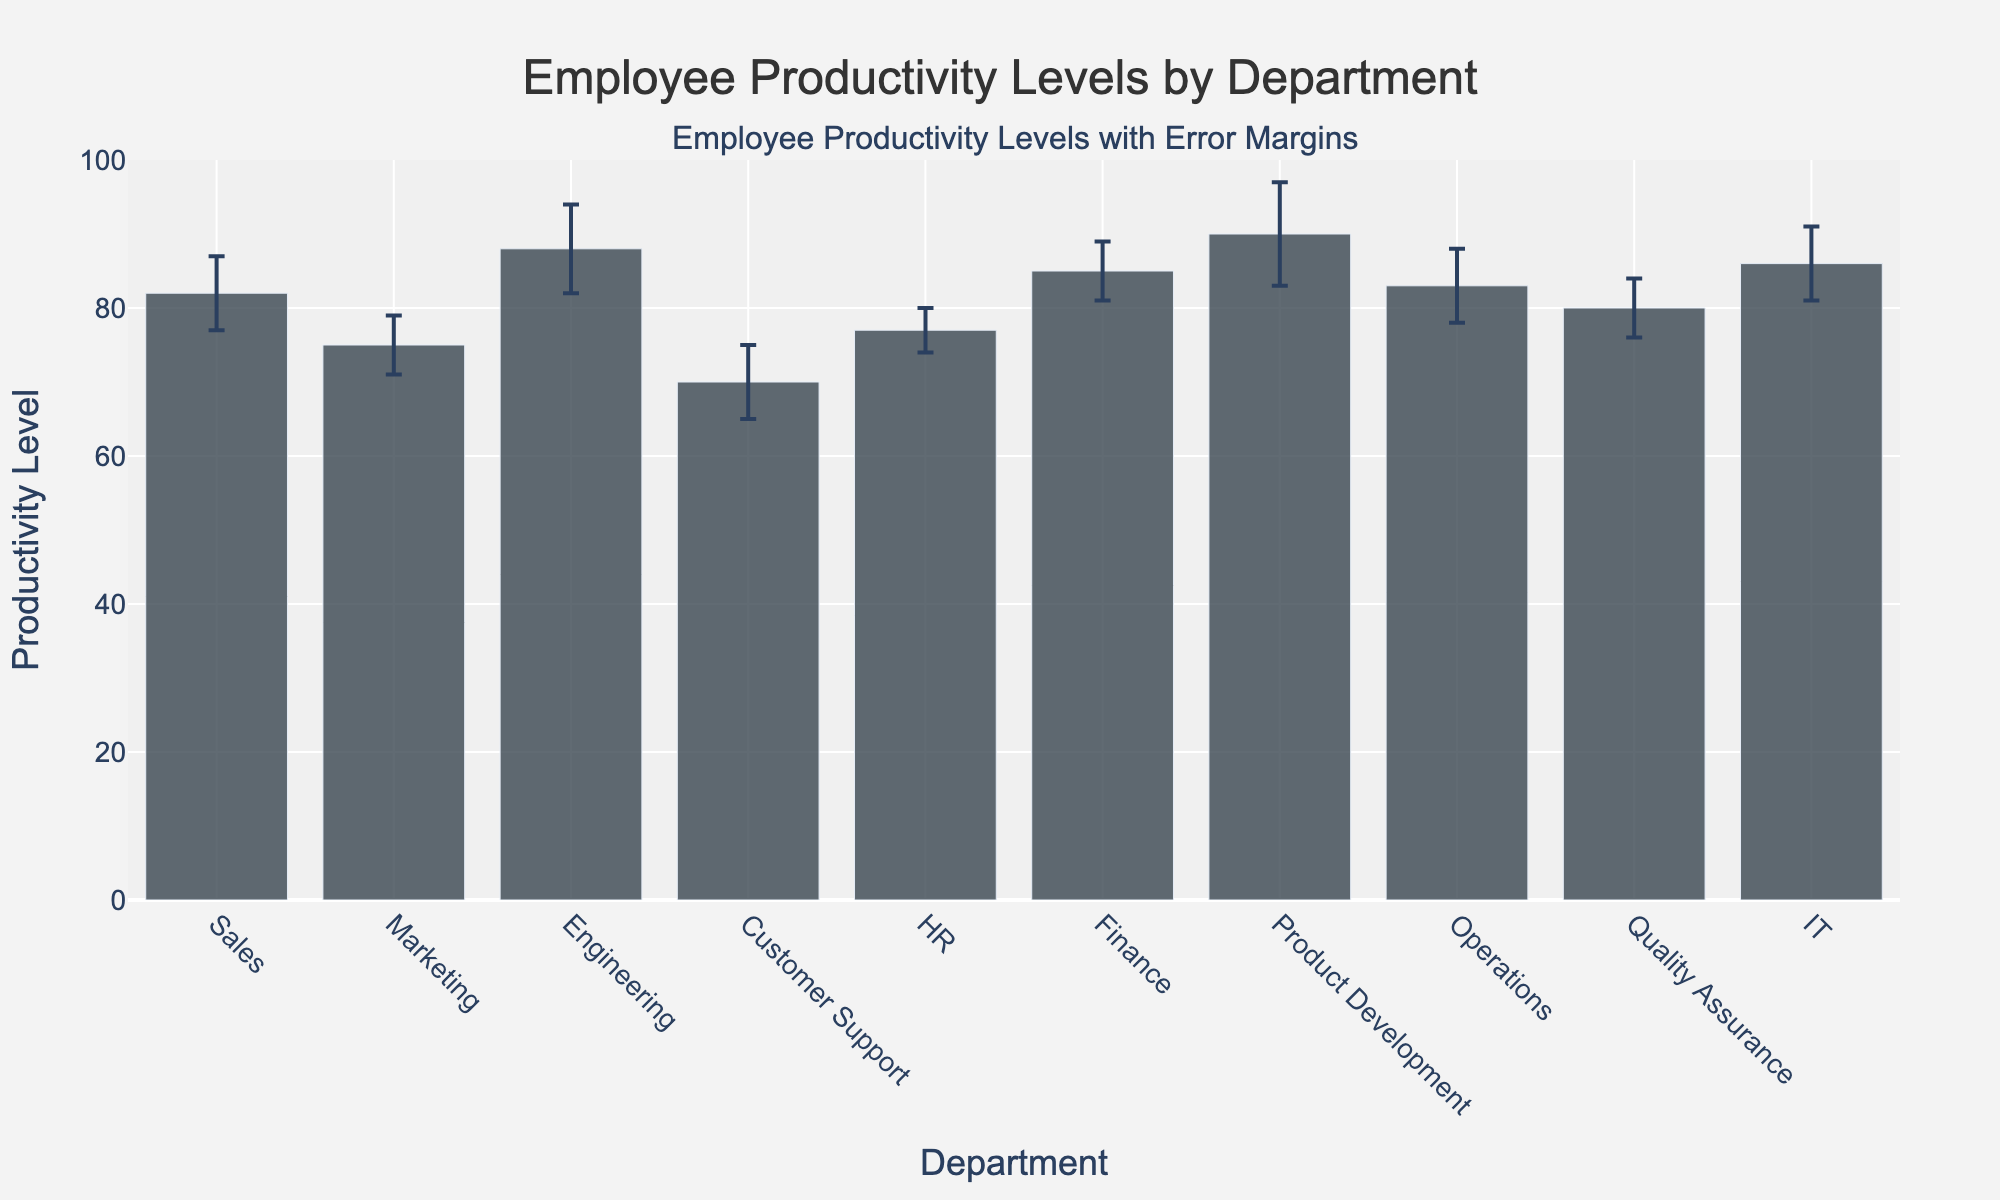What's the title of the figure? The title of the figure usually appears at the top and summarizes the main focus of the plot. Here, it is stated as "Employee Productivity Levels by Department".
Answer: Employee Productivity Levels by Department What is the average productivity level across all departments? First, sum the Mean_Productivity values: 82 + 75 + 88 + 70 + 77 + 85 + 90 + 83 + 80 + 86 = 836. Then, divide by the number of departments (10): 836 / 10 = 83.6.
Answer: 83.6 Which department has the highest productivity level? The department with the highest bar and value is "Product Development" with a Mean_Productivity of 90.
Answer: Product Development What is the difference in productivity levels between the IT and Customer Support departments? IT has a Mean_Productivity of 86 and Customer Support has 70. The difference is 86 - 70 = 16.
Answer: 16 Which departments have an error margin of 5? By observing the error bars, the departments with an error margin of 5 are Sales, Customer Support, Operations, and IT.
Answer: Sales, Customer Support, Operations, IT What is the range of the y-axis? The y-axis range can be read from the plot, showing values from 0 to 100.
Answer: 0 to 100 How does the productivity level of Marketing compare to Finance? The Mean_Productivity of Marketing is 75, and for Finance, it is 85. Marketing's productivity is lower than Finance's by 85 - 75 = 10.
Answer: 10 lower Which department has the smallest error margin, and what is its value? By checking the error bars, HR has the smallest error margin of 3.
Answer: HR, 3 List the departments with a productivity level above 80. Departments with Mean_Productivity above 80 are Sales (82), Engineering (88), Finance (85), Product Development (90), Operations (83), and IT (86).
Answer: Sales, Engineering, Finance, Product Development, Operations, IT What is the combined productivity level of the Sales and Marketing departments? Adding the Mean_Productivities of Sales (82) and Marketing (75) yields 82 + 75 = 157.
Answer: 157 